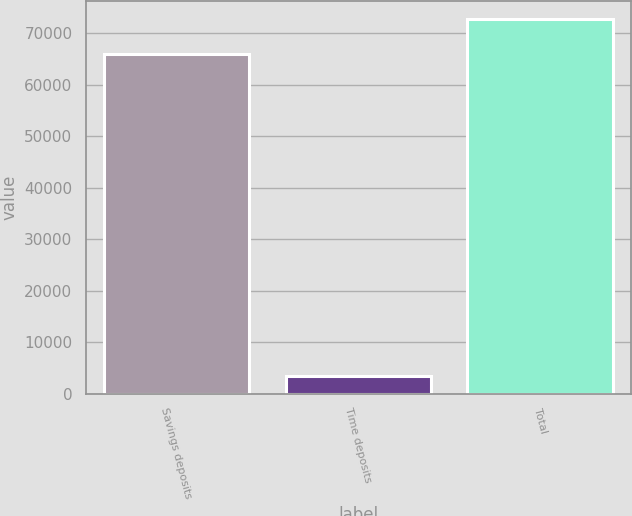<chart> <loc_0><loc_0><loc_500><loc_500><bar_chart><fcel>Savings deposits<fcel>Time deposits<fcel>Total<nl><fcel>66073<fcel>3357<fcel>72680.3<nl></chart> 